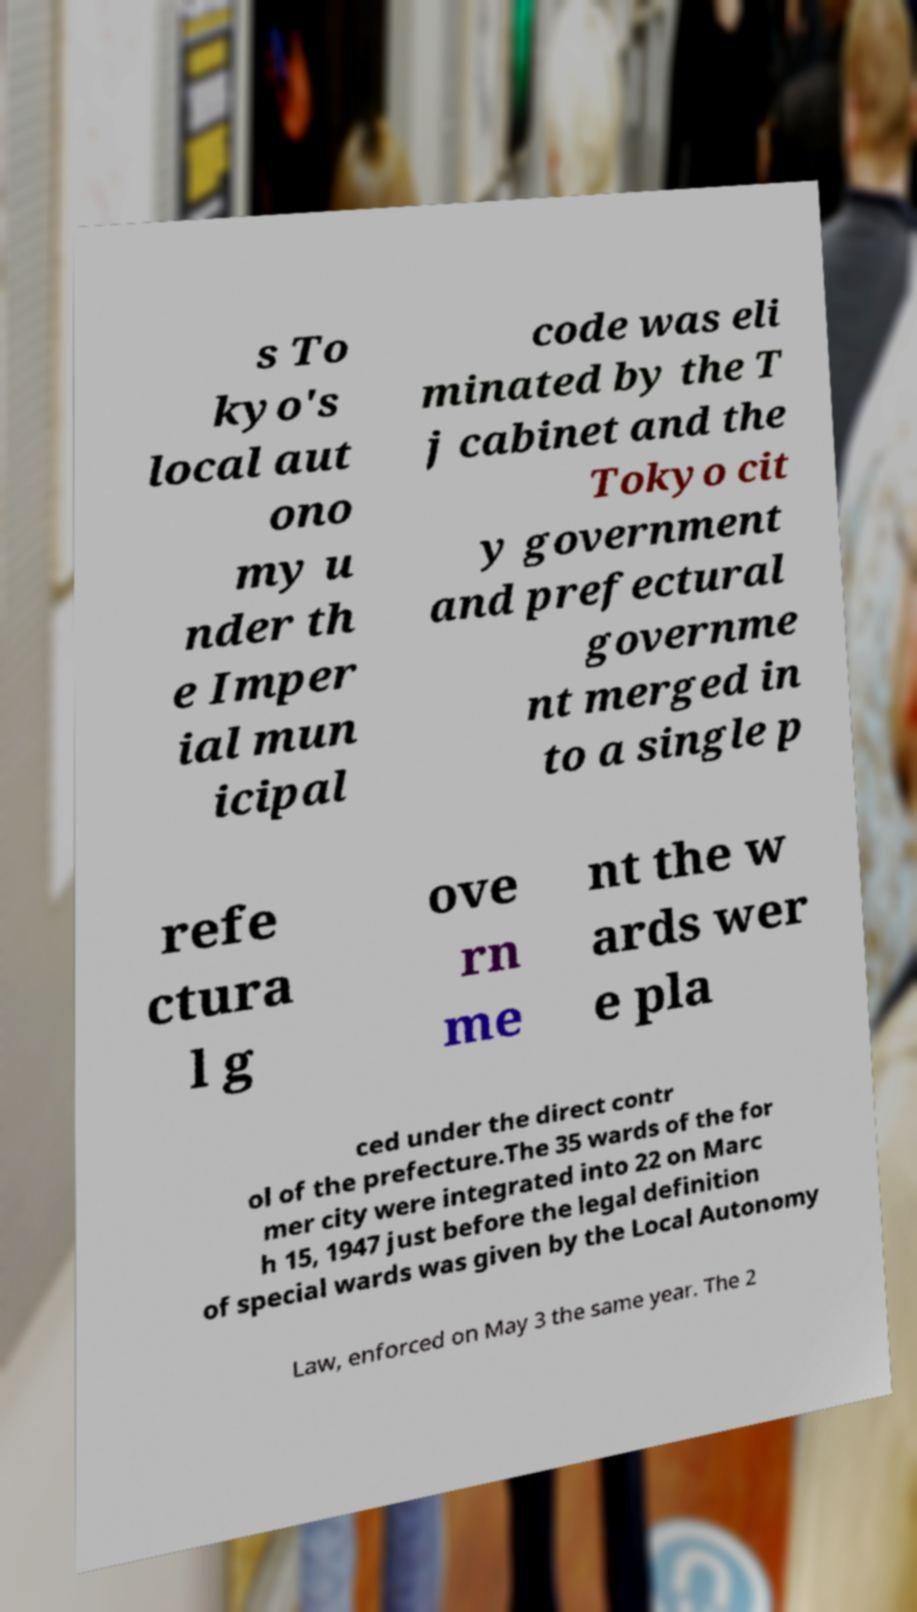Could you assist in decoding the text presented in this image and type it out clearly? s To kyo's local aut ono my u nder th e Imper ial mun icipal code was eli minated by the T j cabinet and the Tokyo cit y government and prefectural governme nt merged in to a single p refe ctura l g ove rn me nt the w ards wer e pla ced under the direct contr ol of the prefecture.The 35 wards of the for mer city were integrated into 22 on Marc h 15, 1947 just before the legal definition of special wards was given by the Local Autonomy Law, enforced on May 3 the same year. The 2 